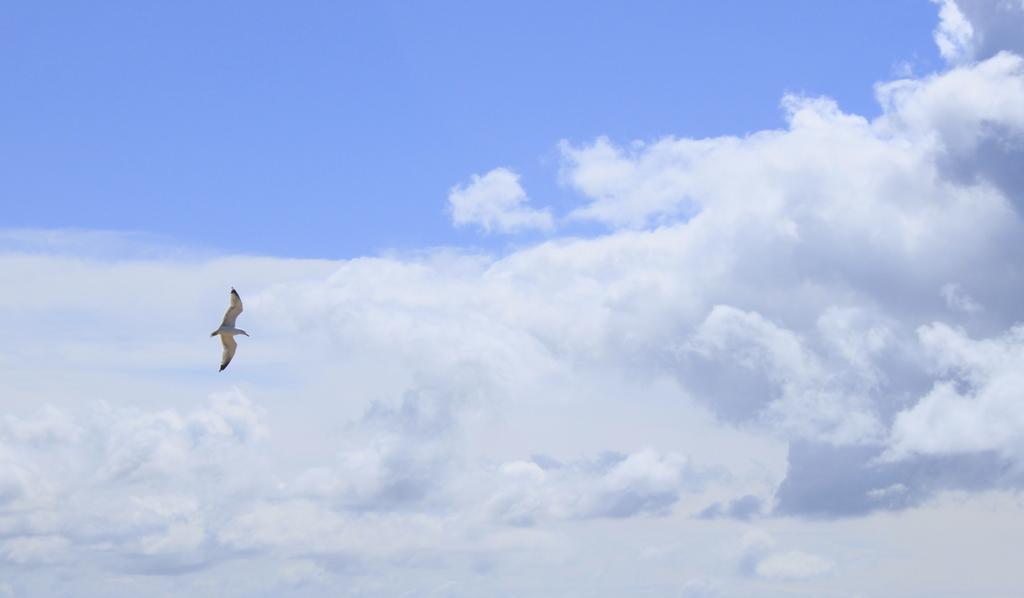How would you summarize this image in a sentence or two? In this picture, we see a bird which is flying in the sky. In the background, we see the clouds and the sky, which is blue in color. 